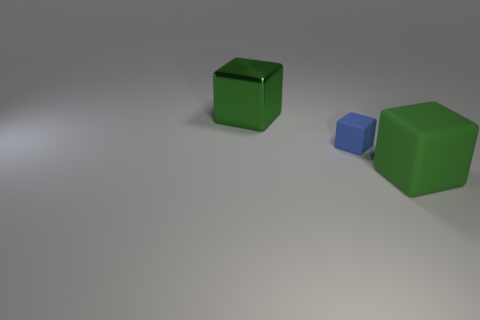How many other things are there of the same size as the blue cube?
Keep it short and to the point. 0. There is a tiny thing; are there any things behind it?
Your answer should be very brief. Yes. There is a metallic block; is it the same color as the large cube in front of the large green shiny block?
Keep it short and to the point. Yes. What color is the large cube on the left side of the green block that is in front of the metallic thing behind the tiny blue matte thing?
Keep it short and to the point. Green. Are there any brown matte objects that have the same shape as the blue matte thing?
Your answer should be very brief. No. There is a thing that is the same size as the shiny block; what color is it?
Ensure brevity in your answer.  Green. There is a green thing in front of the large shiny cube; what is its material?
Keep it short and to the point. Rubber. Does the green object that is right of the green shiny block have the same shape as the green metallic object that is behind the small blue matte object?
Make the answer very short. Yes. Is the number of blue blocks that are right of the green matte thing the same as the number of tiny gray balls?
Offer a very short reply. Yes. What number of large red spheres are made of the same material as the small blue object?
Your answer should be compact. 0. 